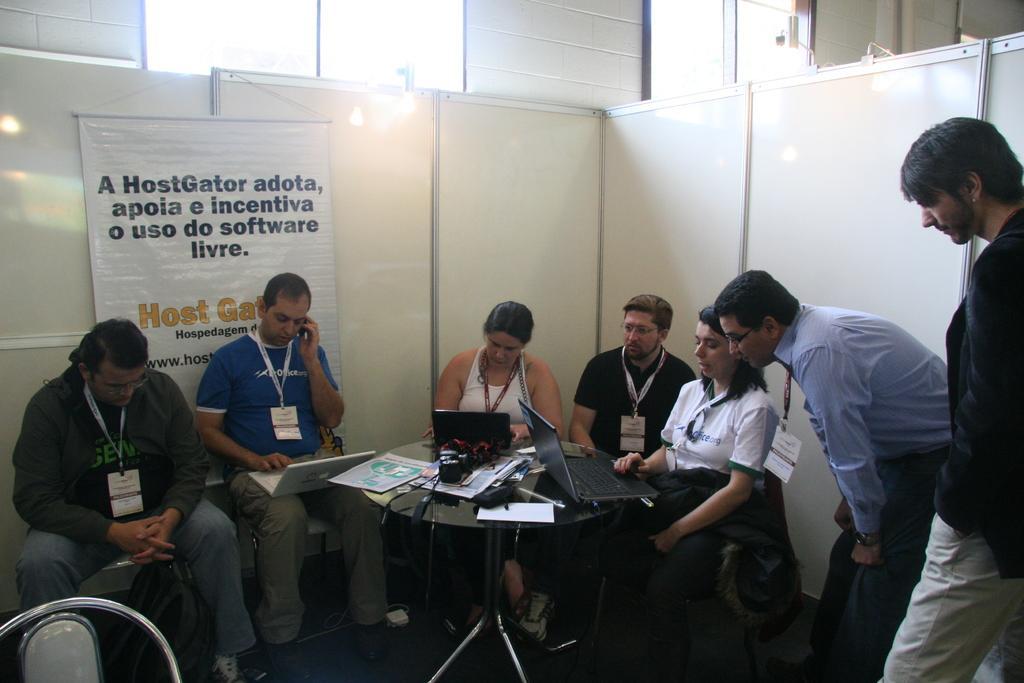Describe this image in one or two sentences. A banner on wall. These persons are sitting on a chair and wore id cards. This man is working on a laptop. On this table there are laptops, papers and things. These two persons are standing. These 2 persons are looking at this laptop and working. On floor there is a bag. 